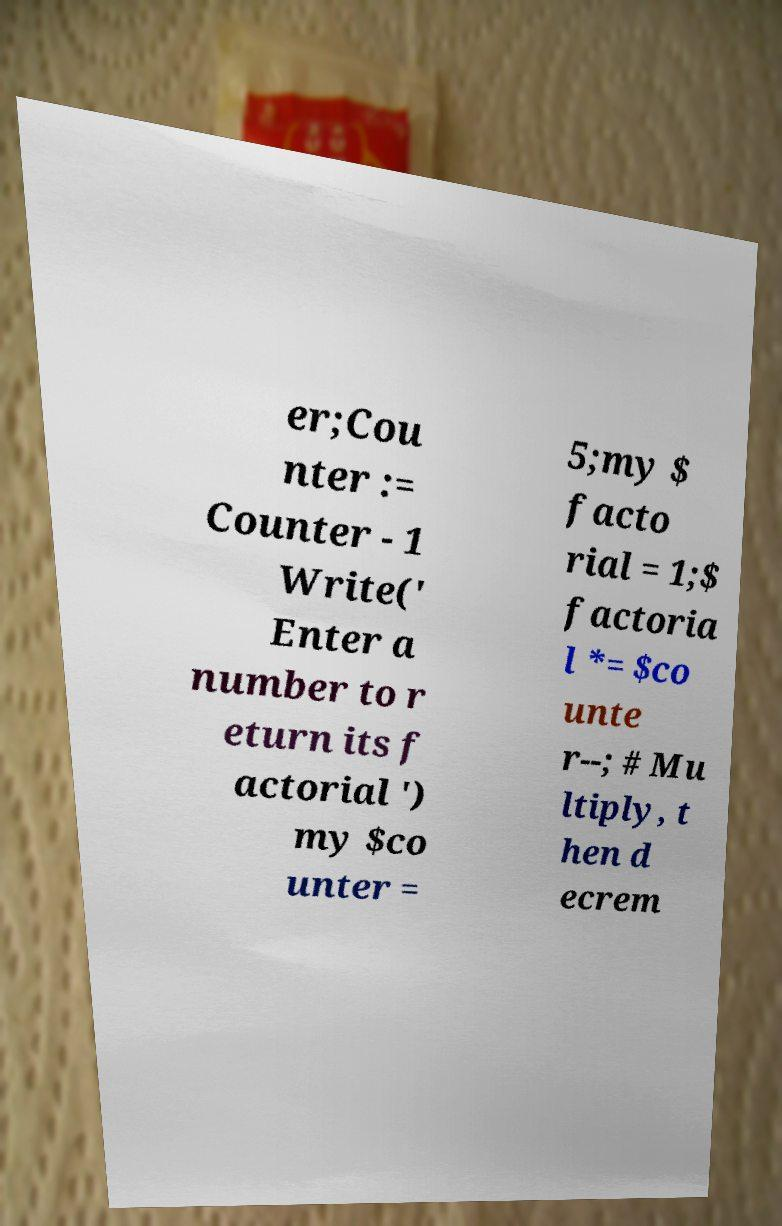Can you read and provide the text displayed in the image?This photo seems to have some interesting text. Can you extract and type it out for me? er;Cou nter := Counter - 1 Write(' Enter a number to r eturn its f actorial ') my $co unter = 5;my $ facto rial = 1;$ factoria l *= $co unte r--; # Mu ltiply, t hen d ecrem 